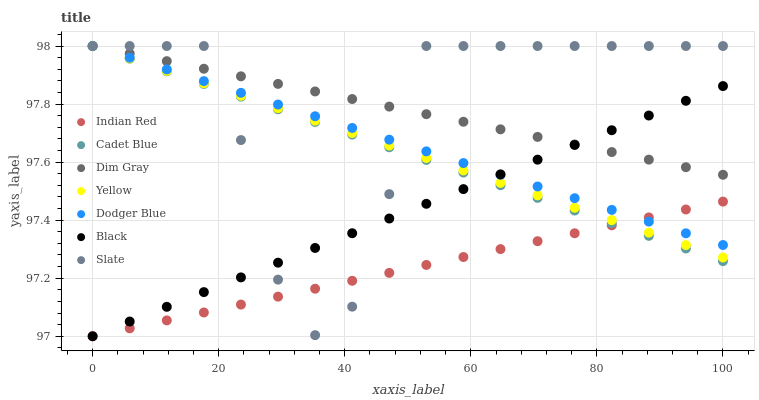Does Indian Red have the minimum area under the curve?
Answer yes or no. Yes. Does Slate have the maximum area under the curve?
Answer yes or no. Yes. Does Yellow have the minimum area under the curve?
Answer yes or no. No. Does Yellow have the maximum area under the curve?
Answer yes or no. No. Is Dodger Blue the smoothest?
Answer yes or no. Yes. Is Slate the roughest?
Answer yes or no. Yes. Is Yellow the smoothest?
Answer yes or no. No. Is Yellow the roughest?
Answer yes or no. No. Does Black have the lowest value?
Answer yes or no. Yes. Does Slate have the lowest value?
Answer yes or no. No. Does Dodger Blue have the highest value?
Answer yes or no. Yes. Does Black have the highest value?
Answer yes or no. No. Is Indian Red less than Dim Gray?
Answer yes or no. Yes. Is Dim Gray greater than Indian Red?
Answer yes or no. Yes. Does Dodger Blue intersect Black?
Answer yes or no. Yes. Is Dodger Blue less than Black?
Answer yes or no. No. Is Dodger Blue greater than Black?
Answer yes or no. No. Does Indian Red intersect Dim Gray?
Answer yes or no. No. 